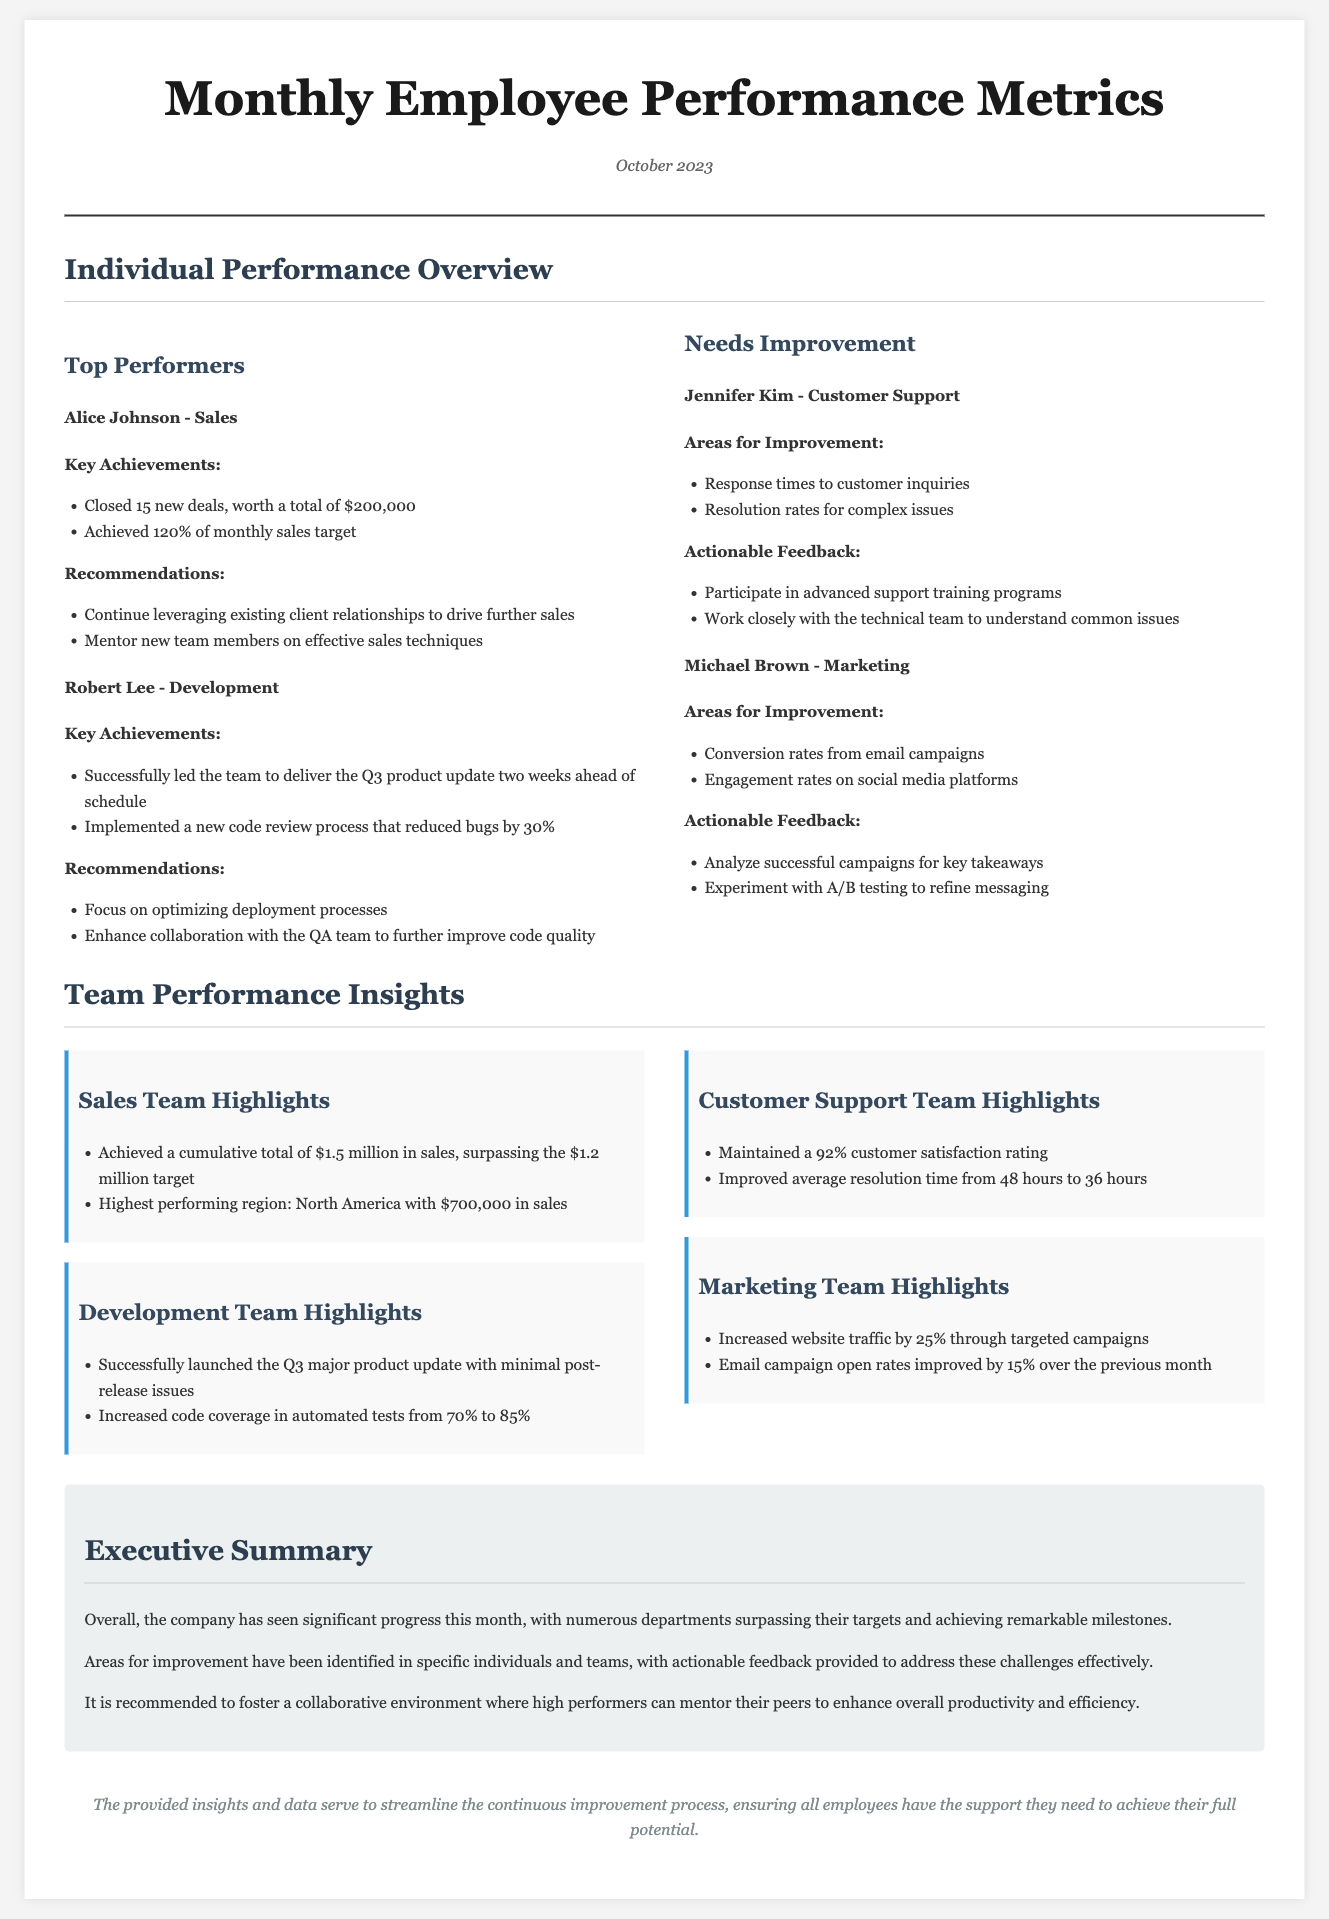What was the total number of new deals closed by Alice Johnson? Alice Johnson closed 15 new deals, worth a total of $200,000, as stated in the document.
Answer: 15 What percentage of the monthly sales target did Alice Johnson achieve? Alice Johnson achieved 120% of her monthly sales target, which is mentioned in her performance overview.
Answer: 120% Which team maintained a 92% customer satisfaction rating? The Customer Support Team achieved a 92% customer satisfaction rating according to the highlights.
Answer: Customer Support Team What area for improvement was noted for Michael Brown? The document specifies that Michael Brown needs to improve conversion rates from email campaigns and engagement rates on social media platforms.
Answer: Conversion rates from email campaigns How much was the cumulative total of sales achieved by the Sales Team? The Sales Team achieved a cumulative total of $1.5 million in sales, exceeding their target as reported in the team performance insights.
Answer: $1.5 million What is the main focus for Robert Lee's improvement? The recommendations for Robert Lee emphasize focusing on optimizing deployment processes as highlighted in his overview.
Answer: Optimizing deployment processes Which month does this employee performance report cover? The report is for October 2023, as indicated in the header of the document.
Answer: October 2023 What notable achievement did the Development Team highlight? The Development Team successfully launched the Q3 major product update with minimal post-release issues, according to the highlights.
Answer: Launched the Q3 major product update What specific training program should Jennifer Kim participate in? Jennifer Kim is advised to participate in advanced support training programs for improvement as noted in her section.
Answer: Advanced support training programs 